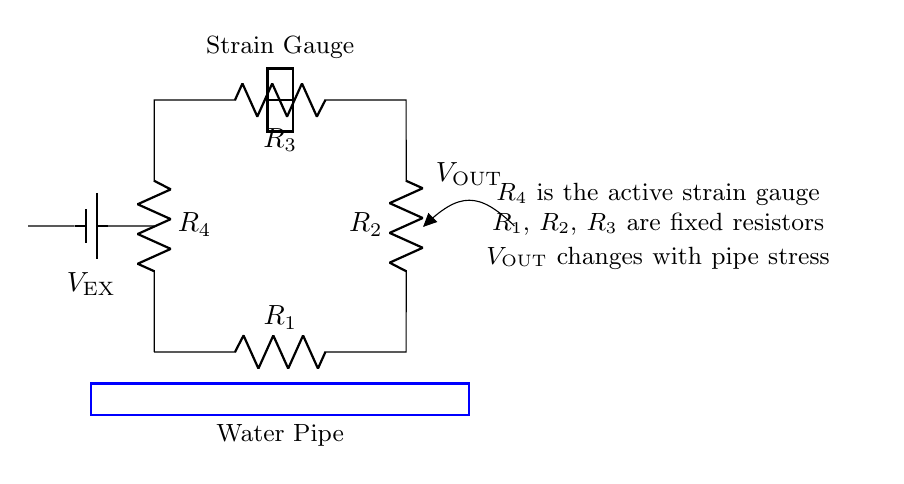What type of circuit is shown? The circuit is a bridge circuit, specifically a strain gauge bridge that measures resistance changes in response to stress.
Answer: Bridge circuit What is the role of R4 in this circuit? R4 is the active strain gauge that changes its resistance according to the stress applied to the water pipes, affecting the output voltage.
Answer: Active strain gauge What does VOUT represent in the circuit? VOUT is the output voltage that indicates the change in resistance due to stress on the strain gauge, providing a measurable signal.
Answer: Output voltage How many resistors are in this circuit? The circuit contains four resistors, labeled R1, R2, R3, and R4, which are part of the bridge configuration.
Answer: Four resistors Why is R4 used as an active component? R4 is used as an active component because it is a strain gauge, which reacts to physical stress, causing a change in its resistance and therefore the balance of the bridge.
Answer: Strain gauge What connects the power supply to the rest of the circuit? The battery connects the power supply, providing an excitation voltage (VEX) to the circuit for operation.
Answer: Battery 